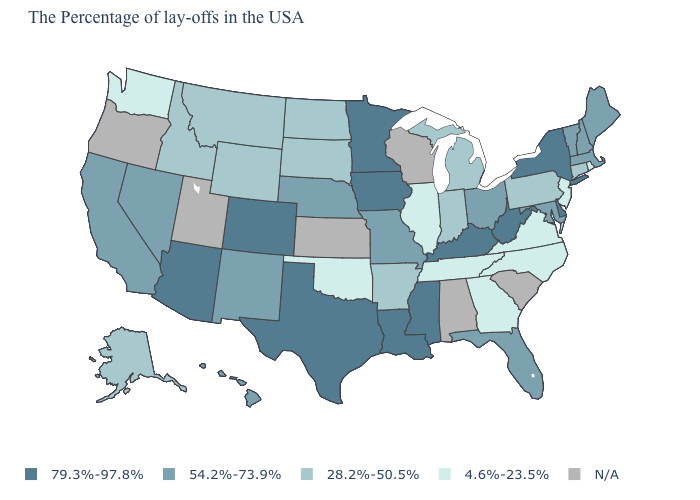Among the states that border Georgia , does North Carolina have the highest value?
Keep it brief. No. Among the states that border Massachusetts , does Rhode Island have the lowest value?
Concise answer only. Yes. What is the value of North Carolina?
Be succinct. 4.6%-23.5%. What is the lowest value in the Northeast?
Be succinct. 4.6%-23.5%. Does the first symbol in the legend represent the smallest category?
Write a very short answer. No. Name the states that have a value in the range 4.6%-23.5%?
Short answer required. Rhode Island, New Jersey, Virginia, North Carolina, Georgia, Tennessee, Illinois, Oklahoma, Washington. What is the highest value in states that border Colorado?
Keep it brief. 79.3%-97.8%. What is the lowest value in the USA?
Short answer required. 4.6%-23.5%. What is the highest value in states that border Michigan?
Give a very brief answer. 54.2%-73.9%. Which states have the lowest value in the USA?
Keep it brief. Rhode Island, New Jersey, Virginia, North Carolina, Georgia, Tennessee, Illinois, Oklahoma, Washington. Does New Mexico have the lowest value in the West?
Be succinct. No. What is the highest value in the USA?
Answer briefly. 79.3%-97.8%. What is the highest value in states that border California?
Quick response, please. 79.3%-97.8%. What is the value of Michigan?
Answer briefly. 28.2%-50.5%. 